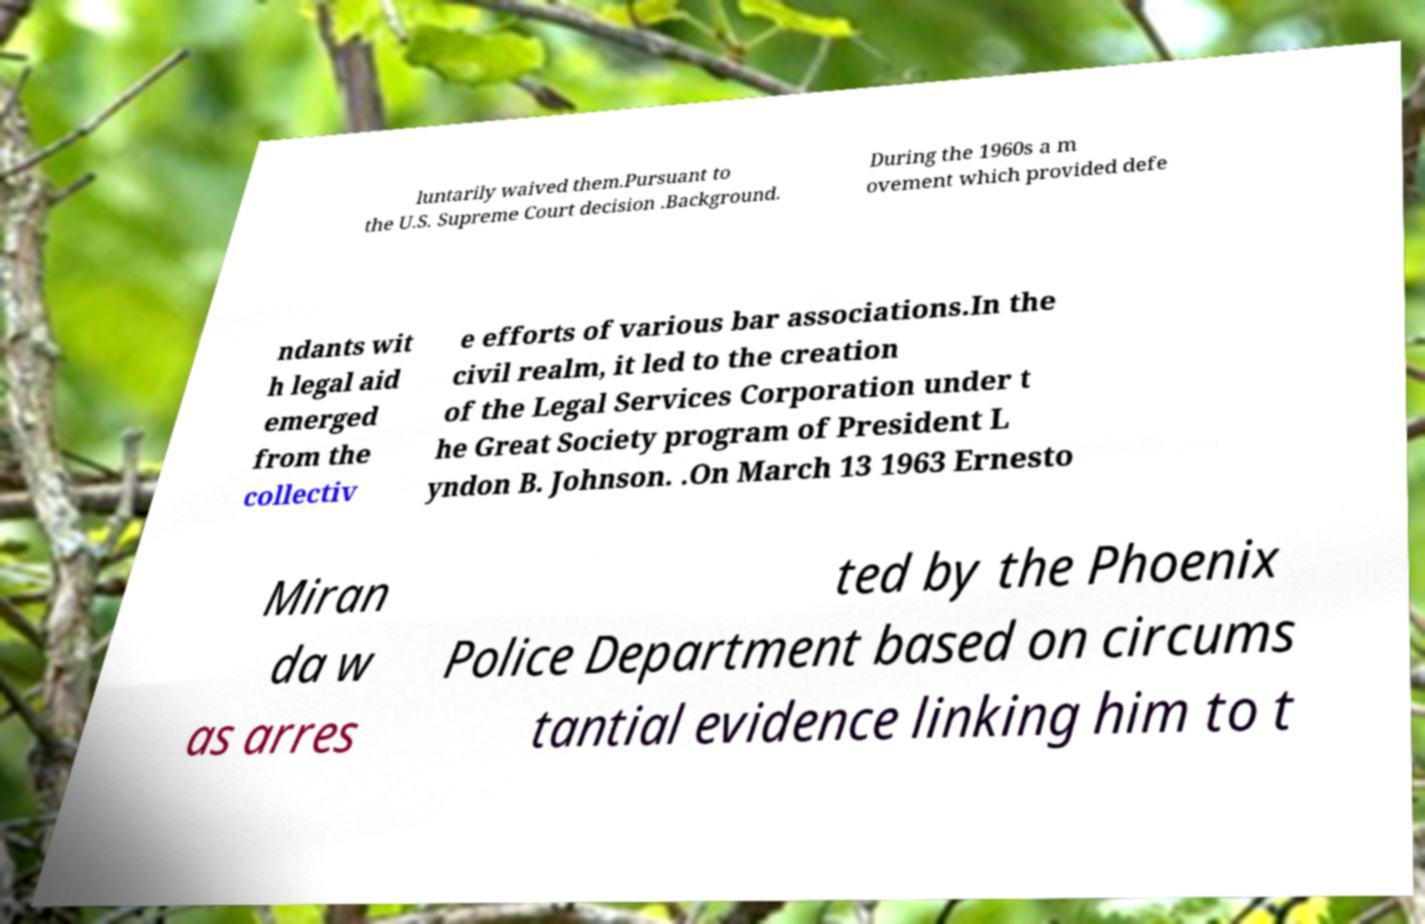Please identify and transcribe the text found in this image. luntarily waived them.Pursuant to the U.S. Supreme Court decision .Background. During the 1960s a m ovement which provided defe ndants wit h legal aid emerged from the collectiv e efforts of various bar associations.In the civil realm, it led to the creation of the Legal Services Corporation under t he Great Society program of President L yndon B. Johnson. .On March 13 1963 Ernesto Miran da w as arres ted by the Phoenix Police Department based on circums tantial evidence linking him to t 